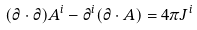Convert formula to latex. <formula><loc_0><loc_0><loc_500><loc_500>( \partial \cdot \partial ) A ^ { i } - \partial ^ { i } ( \partial \cdot A ) = 4 \pi J ^ { i }</formula> 